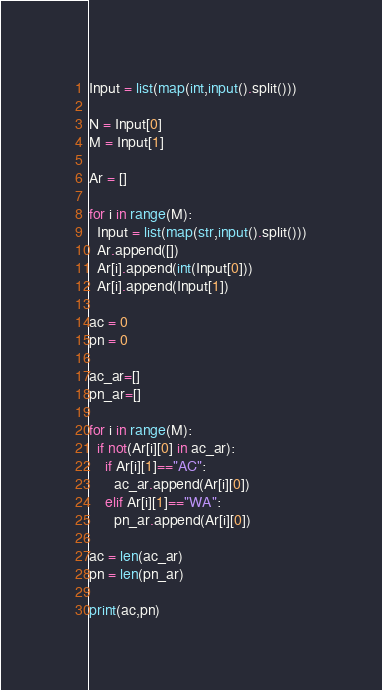<code> <loc_0><loc_0><loc_500><loc_500><_Python_>Input = list(map(int,input().split()))

N = Input[0]
M = Input[1]

Ar = []

for i in range(M):
  Input = list(map(str,input().split()))
  Ar.append([])
  Ar[i].append(int(Input[0]))
  Ar[i].append(Input[1])

ac = 0
pn = 0

ac_ar=[]
pn_ar=[]

for i in range(M):
  if not(Ar[i][0] in ac_ar):
    if Ar[i][1]=="AC":
      ac_ar.append(Ar[i][0])
    elif Ar[i][1]=="WA":
      pn_ar.append(Ar[i][0])

ac = len(ac_ar)
pn = len(pn_ar)

print(ac,pn)</code> 